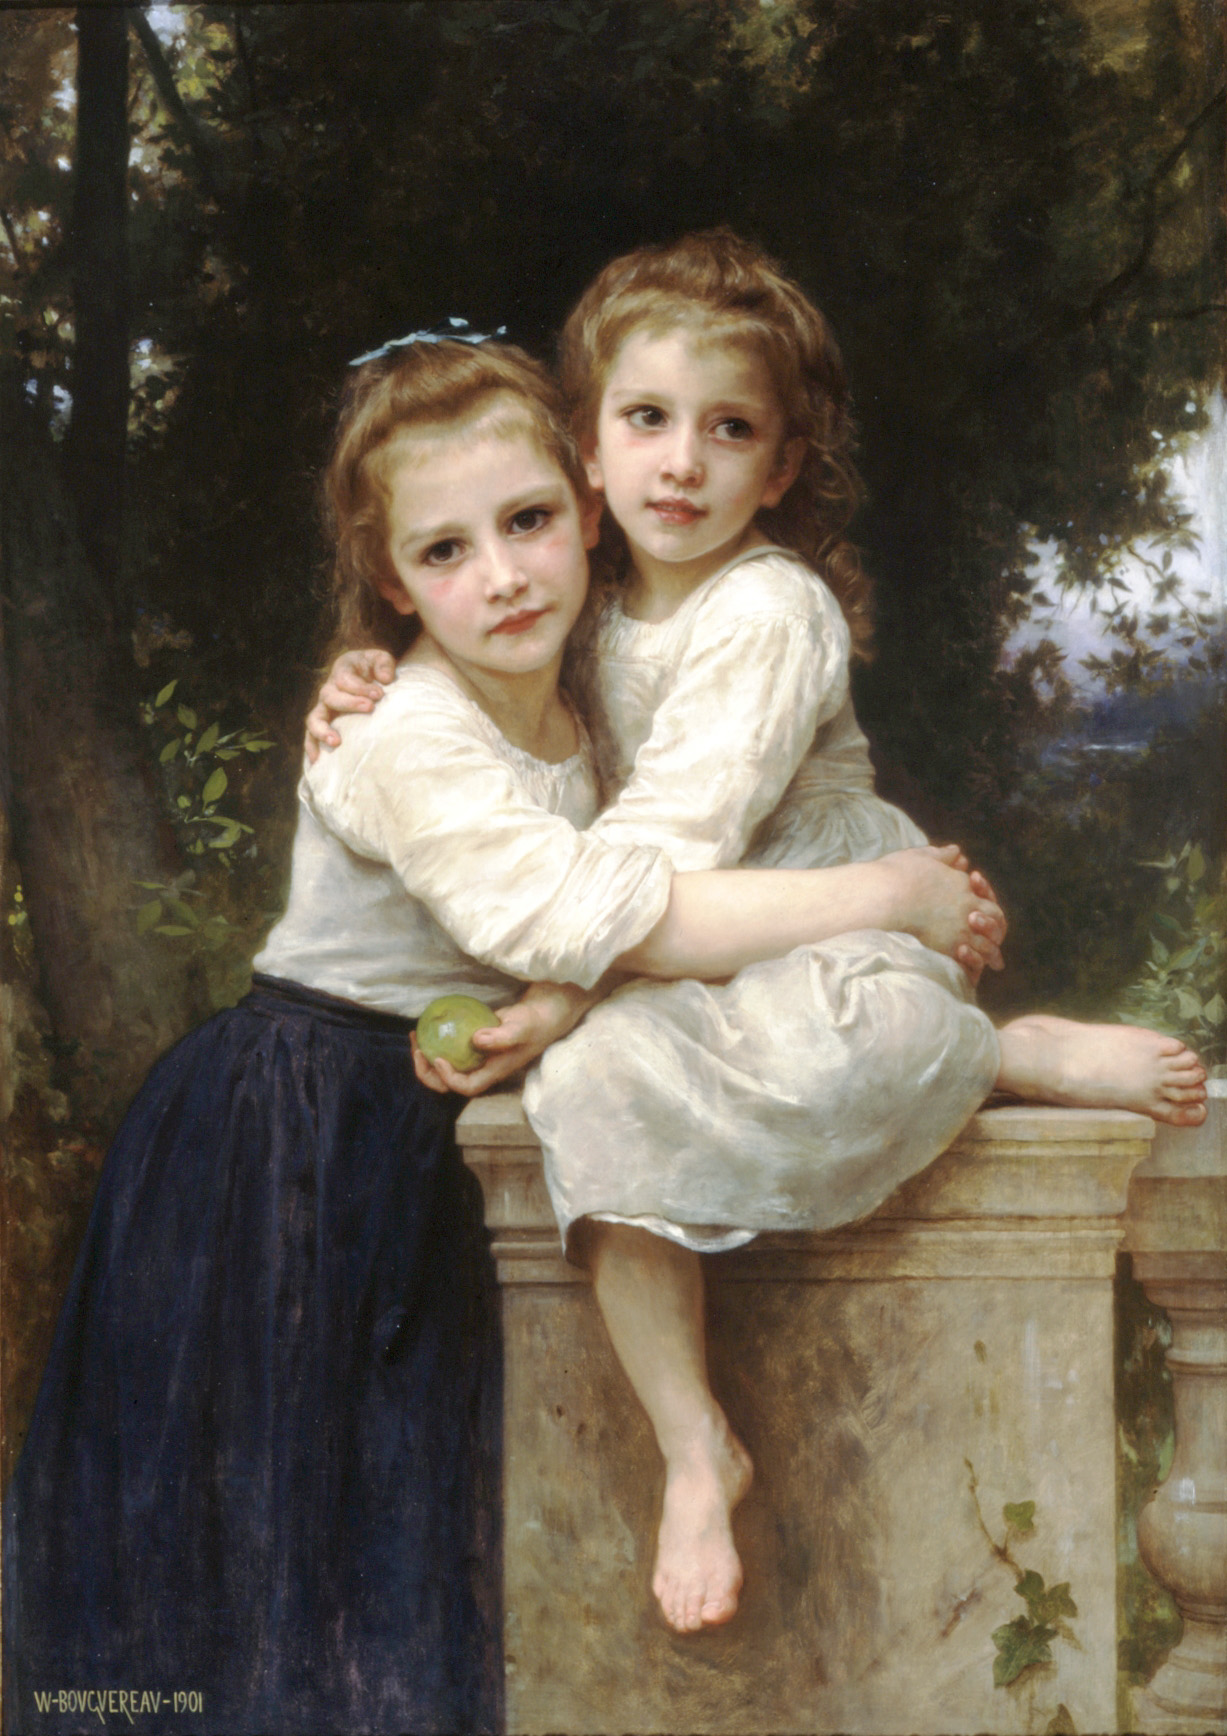Can you describe the main features of this image for me? The image is a stunning oil painting that harks back to a bygone era. It depicts two young girls who exude innocence and grace as they share a gentle embrace. The girls are seated on a stone balustrade, their pure white dresses forming a striking contrast against the verdant foliage that surrounds them. The artist has carefully detailed their hair, adorned with delicate blue ribbons, which injects a pop of color into the serene scene. The background is lush with greenery, creating an idyllic and tranquil garden setting. The painting, which appears to be in a realist style from the 19th century, showcases the artist's remarkable ability to manipulate light and shadow, lending a lifelike quality to the work. The harmonious composition, blending colors and textures seamlessly, invites viewers to revel in its nostalgic charm. 